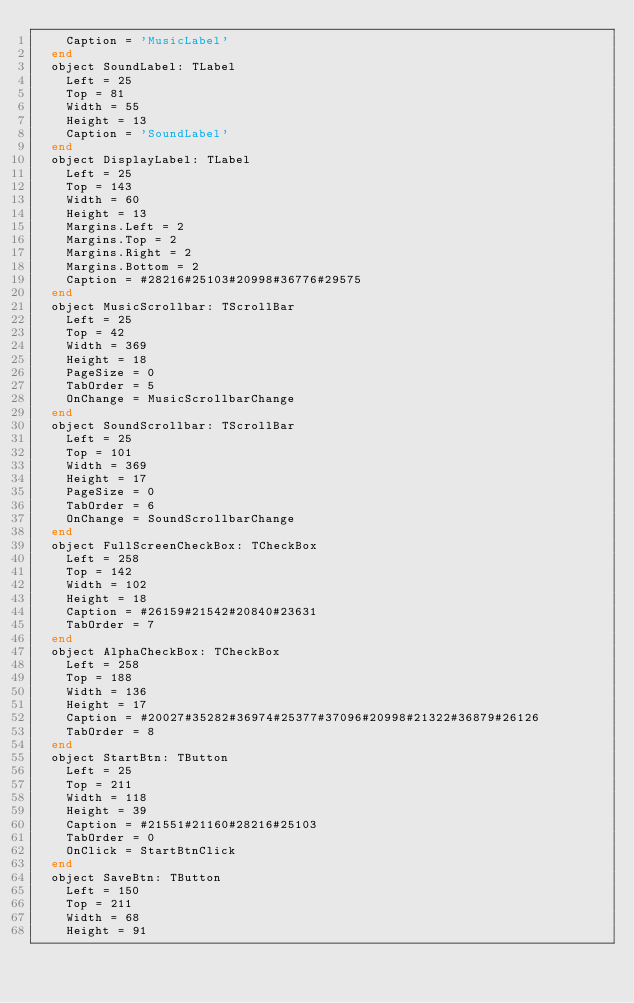<code> <loc_0><loc_0><loc_500><loc_500><_Pascal_>    Caption = 'MusicLabel'
  end
  object SoundLabel: TLabel
    Left = 25
    Top = 81
    Width = 55
    Height = 13
    Caption = 'SoundLabel'
  end
  object DisplayLabel: TLabel
    Left = 25
    Top = 143
    Width = 60
    Height = 13
    Margins.Left = 2
    Margins.Top = 2
    Margins.Right = 2
    Margins.Bottom = 2
    Caption = #28216#25103#20998#36776#29575
  end
  object MusicScrollbar: TScrollBar
    Left = 25
    Top = 42
    Width = 369
    Height = 18
    PageSize = 0
    TabOrder = 5
    OnChange = MusicScrollbarChange
  end
  object SoundScrollbar: TScrollBar
    Left = 25
    Top = 101
    Width = 369
    Height = 17
    PageSize = 0
    TabOrder = 6
    OnChange = SoundScrollbarChange
  end
  object FullScreenCheckBox: TCheckBox
    Left = 258
    Top = 142
    Width = 102
    Height = 18
    Caption = #26159#21542#20840#23631
    TabOrder = 7
  end
  object AlphaCheckBox: TCheckBox
    Left = 258
    Top = 188
    Width = 136
    Height = 17
    Caption = #20027#35282#36974#25377#37096#20998#21322#36879#26126
    TabOrder = 8
  end
  object StartBtn: TButton
    Left = 25
    Top = 211
    Width = 118
    Height = 39
    Caption = #21551#21160#28216#25103
    TabOrder = 0
    OnClick = StartBtnClick
  end
  object SaveBtn: TButton
    Left = 150
    Top = 211
    Width = 68
    Height = 91</code> 